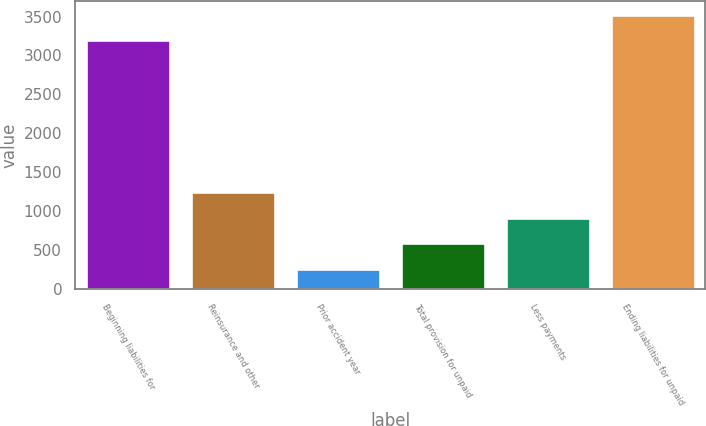<chart> <loc_0><loc_0><loc_500><loc_500><bar_chart><fcel>Beginning liabilities for<fcel>Reinsurance and other<fcel>Prior accident year<fcel>Total provision for unpaid<fcel>Less payments<fcel>Ending liabilities for unpaid<nl><fcel>3196.6<fcel>1246.8<fcel>261<fcel>589.6<fcel>918.2<fcel>3525.2<nl></chart> 